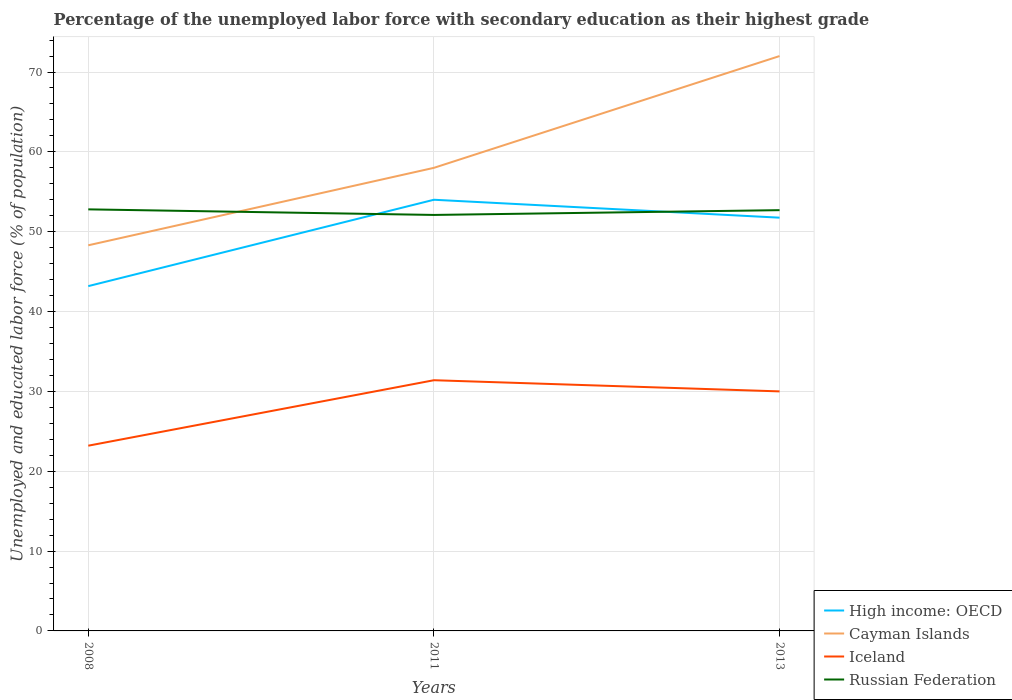How many different coloured lines are there?
Provide a short and direct response. 4. Does the line corresponding to Iceland intersect with the line corresponding to High income: OECD?
Ensure brevity in your answer.  No. Is the number of lines equal to the number of legend labels?
Give a very brief answer. Yes. Across all years, what is the maximum percentage of the unemployed labor force with secondary education in Russian Federation?
Your answer should be compact. 52.1. In which year was the percentage of the unemployed labor force with secondary education in Iceland maximum?
Keep it short and to the point. 2008. What is the total percentage of the unemployed labor force with secondary education in Cayman Islands in the graph?
Your answer should be compact. -23.7. What is the difference between the highest and the second highest percentage of the unemployed labor force with secondary education in Russian Federation?
Keep it short and to the point. 0.7. What is the difference between the highest and the lowest percentage of the unemployed labor force with secondary education in Iceland?
Provide a short and direct response. 2. How many lines are there?
Your response must be concise. 4. What is the difference between two consecutive major ticks on the Y-axis?
Ensure brevity in your answer.  10. How many legend labels are there?
Offer a terse response. 4. How are the legend labels stacked?
Your response must be concise. Vertical. What is the title of the graph?
Your answer should be compact. Percentage of the unemployed labor force with secondary education as their highest grade. What is the label or title of the Y-axis?
Your answer should be compact. Unemployed and educated labor force (% of population). What is the Unemployed and educated labor force (% of population) in High income: OECD in 2008?
Give a very brief answer. 43.18. What is the Unemployed and educated labor force (% of population) of Cayman Islands in 2008?
Offer a very short reply. 48.3. What is the Unemployed and educated labor force (% of population) of Iceland in 2008?
Offer a terse response. 23.2. What is the Unemployed and educated labor force (% of population) in Russian Federation in 2008?
Ensure brevity in your answer.  52.8. What is the Unemployed and educated labor force (% of population) in High income: OECD in 2011?
Offer a very short reply. 54. What is the Unemployed and educated labor force (% of population) in Iceland in 2011?
Your answer should be very brief. 31.4. What is the Unemployed and educated labor force (% of population) in Russian Federation in 2011?
Your answer should be very brief. 52.1. What is the Unemployed and educated labor force (% of population) in High income: OECD in 2013?
Provide a short and direct response. 51.76. What is the Unemployed and educated labor force (% of population) in Cayman Islands in 2013?
Offer a very short reply. 72. What is the Unemployed and educated labor force (% of population) of Russian Federation in 2013?
Provide a succinct answer. 52.7. Across all years, what is the maximum Unemployed and educated labor force (% of population) of High income: OECD?
Your response must be concise. 54. Across all years, what is the maximum Unemployed and educated labor force (% of population) in Iceland?
Ensure brevity in your answer.  31.4. Across all years, what is the maximum Unemployed and educated labor force (% of population) in Russian Federation?
Make the answer very short. 52.8. Across all years, what is the minimum Unemployed and educated labor force (% of population) in High income: OECD?
Offer a terse response. 43.18. Across all years, what is the minimum Unemployed and educated labor force (% of population) of Cayman Islands?
Provide a succinct answer. 48.3. Across all years, what is the minimum Unemployed and educated labor force (% of population) in Iceland?
Make the answer very short. 23.2. Across all years, what is the minimum Unemployed and educated labor force (% of population) in Russian Federation?
Keep it short and to the point. 52.1. What is the total Unemployed and educated labor force (% of population) in High income: OECD in the graph?
Your answer should be compact. 148.95. What is the total Unemployed and educated labor force (% of population) in Cayman Islands in the graph?
Your answer should be compact. 178.3. What is the total Unemployed and educated labor force (% of population) of Iceland in the graph?
Ensure brevity in your answer.  84.6. What is the total Unemployed and educated labor force (% of population) of Russian Federation in the graph?
Keep it short and to the point. 157.6. What is the difference between the Unemployed and educated labor force (% of population) of High income: OECD in 2008 and that in 2011?
Your answer should be very brief. -10.82. What is the difference between the Unemployed and educated labor force (% of population) in High income: OECD in 2008 and that in 2013?
Keep it short and to the point. -8.57. What is the difference between the Unemployed and educated labor force (% of population) of Cayman Islands in 2008 and that in 2013?
Make the answer very short. -23.7. What is the difference between the Unemployed and educated labor force (% of population) in Iceland in 2008 and that in 2013?
Ensure brevity in your answer.  -6.8. What is the difference between the Unemployed and educated labor force (% of population) in Russian Federation in 2008 and that in 2013?
Provide a short and direct response. 0.1. What is the difference between the Unemployed and educated labor force (% of population) in High income: OECD in 2011 and that in 2013?
Offer a very short reply. 2.24. What is the difference between the Unemployed and educated labor force (% of population) of Iceland in 2011 and that in 2013?
Your answer should be compact. 1.4. What is the difference between the Unemployed and educated labor force (% of population) of Russian Federation in 2011 and that in 2013?
Ensure brevity in your answer.  -0.6. What is the difference between the Unemployed and educated labor force (% of population) in High income: OECD in 2008 and the Unemployed and educated labor force (% of population) in Cayman Islands in 2011?
Offer a very short reply. -14.82. What is the difference between the Unemployed and educated labor force (% of population) in High income: OECD in 2008 and the Unemployed and educated labor force (% of population) in Iceland in 2011?
Your answer should be compact. 11.78. What is the difference between the Unemployed and educated labor force (% of population) of High income: OECD in 2008 and the Unemployed and educated labor force (% of population) of Russian Federation in 2011?
Keep it short and to the point. -8.92. What is the difference between the Unemployed and educated labor force (% of population) in Cayman Islands in 2008 and the Unemployed and educated labor force (% of population) in Iceland in 2011?
Ensure brevity in your answer.  16.9. What is the difference between the Unemployed and educated labor force (% of population) of Cayman Islands in 2008 and the Unemployed and educated labor force (% of population) of Russian Federation in 2011?
Make the answer very short. -3.8. What is the difference between the Unemployed and educated labor force (% of population) of Iceland in 2008 and the Unemployed and educated labor force (% of population) of Russian Federation in 2011?
Your answer should be very brief. -28.9. What is the difference between the Unemployed and educated labor force (% of population) of High income: OECD in 2008 and the Unemployed and educated labor force (% of population) of Cayman Islands in 2013?
Give a very brief answer. -28.82. What is the difference between the Unemployed and educated labor force (% of population) in High income: OECD in 2008 and the Unemployed and educated labor force (% of population) in Iceland in 2013?
Keep it short and to the point. 13.18. What is the difference between the Unemployed and educated labor force (% of population) of High income: OECD in 2008 and the Unemployed and educated labor force (% of population) of Russian Federation in 2013?
Provide a short and direct response. -9.52. What is the difference between the Unemployed and educated labor force (% of population) of Iceland in 2008 and the Unemployed and educated labor force (% of population) of Russian Federation in 2013?
Provide a short and direct response. -29.5. What is the difference between the Unemployed and educated labor force (% of population) of High income: OECD in 2011 and the Unemployed and educated labor force (% of population) of Cayman Islands in 2013?
Keep it short and to the point. -18. What is the difference between the Unemployed and educated labor force (% of population) of High income: OECD in 2011 and the Unemployed and educated labor force (% of population) of Iceland in 2013?
Offer a terse response. 24. What is the difference between the Unemployed and educated labor force (% of population) of High income: OECD in 2011 and the Unemployed and educated labor force (% of population) of Russian Federation in 2013?
Offer a very short reply. 1.3. What is the difference between the Unemployed and educated labor force (% of population) of Cayman Islands in 2011 and the Unemployed and educated labor force (% of population) of Russian Federation in 2013?
Your answer should be very brief. 5.3. What is the difference between the Unemployed and educated labor force (% of population) in Iceland in 2011 and the Unemployed and educated labor force (% of population) in Russian Federation in 2013?
Provide a succinct answer. -21.3. What is the average Unemployed and educated labor force (% of population) of High income: OECD per year?
Make the answer very short. 49.65. What is the average Unemployed and educated labor force (% of population) of Cayman Islands per year?
Make the answer very short. 59.43. What is the average Unemployed and educated labor force (% of population) of Iceland per year?
Offer a very short reply. 28.2. What is the average Unemployed and educated labor force (% of population) of Russian Federation per year?
Your response must be concise. 52.53. In the year 2008, what is the difference between the Unemployed and educated labor force (% of population) in High income: OECD and Unemployed and educated labor force (% of population) in Cayman Islands?
Provide a succinct answer. -5.12. In the year 2008, what is the difference between the Unemployed and educated labor force (% of population) in High income: OECD and Unemployed and educated labor force (% of population) in Iceland?
Provide a succinct answer. 19.98. In the year 2008, what is the difference between the Unemployed and educated labor force (% of population) in High income: OECD and Unemployed and educated labor force (% of population) in Russian Federation?
Provide a succinct answer. -9.62. In the year 2008, what is the difference between the Unemployed and educated labor force (% of population) in Cayman Islands and Unemployed and educated labor force (% of population) in Iceland?
Provide a succinct answer. 25.1. In the year 2008, what is the difference between the Unemployed and educated labor force (% of population) in Cayman Islands and Unemployed and educated labor force (% of population) in Russian Federation?
Offer a very short reply. -4.5. In the year 2008, what is the difference between the Unemployed and educated labor force (% of population) in Iceland and Unemployed and educated labor force (% of population) in Russian Federation?
Give a very brief answer. -29.6. In the year 2011, what is the difference between the Unemployed and educated labor force (% of population) in High income: OECD and Unemployed and educated labor force (% of population) in Cayman Islands?
Your answer should be very brief. -4. In the year 2011, what is the difference between the Unemployed and educated labor force (% of population) in High income: OECD and Unemployed and educated labor force (% of population) in Iceland?
Keep it short and to the point. 22.6. In the year 2011, what is the difference between the Unemployed and educated labor force (% of population) of High income: OECD and Unemployed and educated labor force (% of population) of Russian Federation?
Your response must be concise. 1.9. In the year 2011, what is the difference between the Unemployed and educated labor force (% of population) in Cayman Islands and Unemployed and educated labor force (% of population) in Iceland?
Provide a short and direct response. 26.6. In the year 2011, what is the difference between the Unemployed and educated labor force (% of population) of Iceland and Unemployed and educated labor force (% of population) of Russian Federation?
Provide a short and direct response. -20.7. In the year 2013, what is the difference between the Unemployed and educated labor force (% of population) of High income: OECD and Unemployed and educated labor force (% of population) of Cayman Islands?
Your answer should be very brief. -20.24. In the year 2013, what is the difference between the Unemployed and educated labor force (% of population) of High income: OECD and Unemployed and educated labor force (% of population) of Iceland?
Give a very brief answer. 21.76. In the year 2013, what is the difference between the Unemployed and educated labor force (% of population) in High income: OECD and Unemployed and educated labor force (% of population) in Russian Federation?
Give a very brief answer. -0.94. In the year 2013, what is the difference between the Unemployed and educated labor force (% of population) in Cayman Islands and Unemployed and educated labor force (% of population) in Russian Federation?
Your answer should be compact. 19.3. In the year 2013, what is the difference between the Unemployed and educated labor force (% of population) of Iceland and Unemployed and educated labor force (% of population) of Russian Federation?
Your response must be concise. -22.7. What is the ratio of the Unemployed and educated labor force (% of population) of High income: OECD in 2008 to that in 2011?
Your response must be concise. 0.8. What is the ratio of the Unemployed and educated labor force (% of population) in Cayman Islands in 2008 to that in 2011?
Provide a succinct answer. 0.83. What is the ratio of the Unemployed and educated labor force (% of population) in Iceland in 2008 to that in 2011?
Provide a short and direct response. 0.74. What is the ratio of the Unemployed and educated labor force (% of population) in Russian Federation in 2008 to that in 2011?
Give a very brief answer. 1.01. What is the ratio of the Unemployed and educated labor force (% of population) of High income: OECD in 2008 to that in 2013?
Make the answer very short. 0.83. What is the ratio of the Unemployed and educated labor force (% of population) of Cayman Islands in 2008 to that in 2013?
Your answer should be very brief. 0.67. What is the ratio of the Unemployed and educated labor force (% of population) in Iceland in 2008 to that in 2013?
Your answer should be very brief. 0.77. What is the ratio of the Unemployed and educated labor force (% of population) in Russian Federation in 2008 to that in 2013?
Your answer should be very brief. 1. What is the ratio of the Unemployed and educated labor force (% of population) in High income: OECD in 2011 to that in 2013?
Your answer should be very brief. 1.04. What is the ratio of the Unemployed and educated labor force (% of population) of Cayman Islands in 2011 to that in 2013?
Your response must be concise. 0.81. What is the ratio of the Unemployed and educated labor force (% of population) of Iceland in 2011 to that in 2013?
Offer a very short reply. 1.05. What is the ratio of the Unemployed and educated labor force (% of population) of Russian Federation in 2011 to that in 2013?
Give a very brief answer. 0.99. What is the difference between the highest and the second highest Unemployed and educated labor force (% of population) in High income: OECD?
Ensure brevity in your answer.  2.24. What is the difference between the highest and the second highest Unemployed and educated labor force (% of population) of Russian Federation?
Your response must be concise. 0.1. What is the difference between the highest and the lowest Unemployed and educated labor force (% of population) of High income: OECD?
Provide a short and direct response. 10.82. What is the difference between the highest and the lowest Unemployed and educated labor force (% of population) in Cayman Islands?
Your response must be concise. 23.7. 